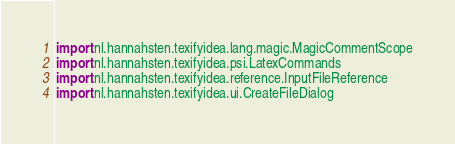Convert code to text. <code><loc_0><loc_0><loc_500><loc_500><_Kotlin_>import nl.hannahsten.texifyidea.lang.magic.MagicCommentScope
import nl.hannahsten.texifyidea.psi.LatexCommands
import nl.hannahsten.texifyidea.reference.InputFileReference
import nl.hannahsten.texifyidea.ui.CreateFileDialog</code> 